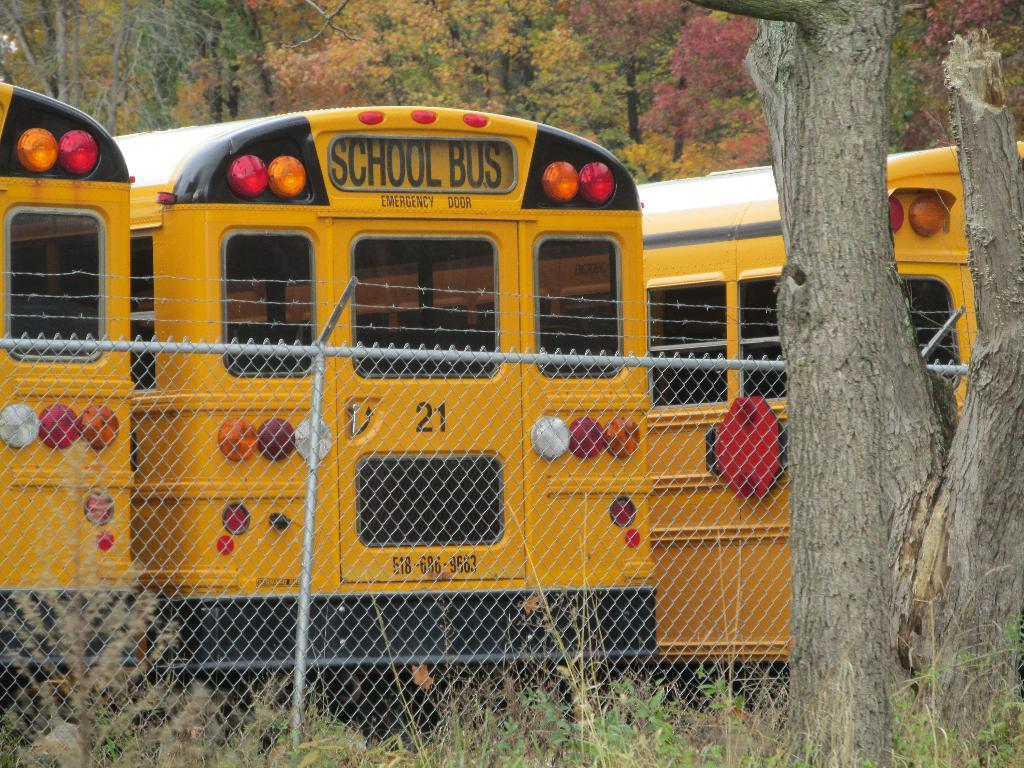How many buses are visible in the image? There are three buses in the image. What is located in the front of the image? There is a fence in the front of the image. What type of vegetation is on the right side of the image? There is a tree to the right of the image. What type of boundary is visible in the image? There is no boundary visible in the image; only a fence is present. How does the tree feel about being in the image? The tree is an inanimate object and does not have feelings, so it cannot feel shame or any other emotion. 